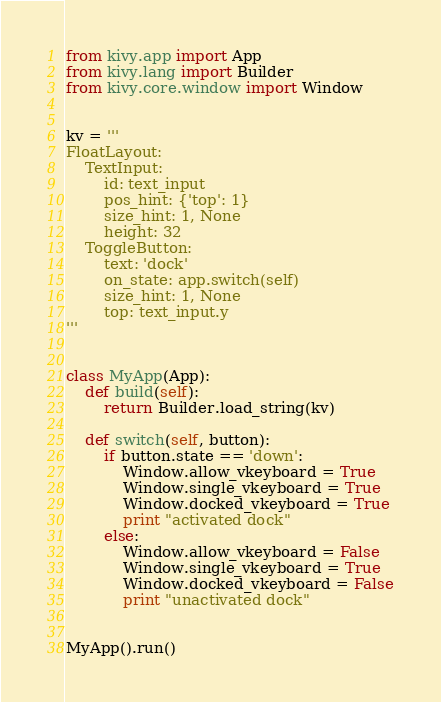<code> <loc_0><loc_0><loc_500><loc_500><_Python_>from kivy.app import App
from kivy.lang import Builder
from kivy.core.window import Window


kv = '''
FloatLayout:
    TextInput:
        id: text_input
        pos_hint: {'top': 1}
        size_hint: 1, None
        height: 32
    ToggleButton:
        text: 'dock'
        on_state: app.switch(self)
        size_hint: 1, None
        top: text_input.y
'''


class MyApp(App):
    def build(self):
        return Builder.load_string(kv)

    def switch(self, button):
        if button.state == 'down':
            Window.allow_vkeyboard = True
            Window.single_vkeyboard = True
            Window.docked_vkeyboard = True
            print "activated dock"
        else:
            Window.allow_vkeyboard = False
            Window.single_vkeyboard = True
            Window.docked_vkeyboard = False
            print "unactivated dock"


MyApp().run()</code> 